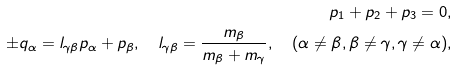Convert formula to latex. <formula><loc_0><loc_0><loc_500><loc_500>p _ { 1 } + p _ { 2 } + p _ { 3 } = 0 , \\ \pm q _ { \alpha } = l _ { \gamma \beta } p _ { \alpha } + p _ { \beta } , \quad l _ { \gamma \beta } = \frac { m _ { \beta } } { m _ { \beta } + m _ { \gamma } } , \quad ( \alpha \neq \beta , \beta \neq \gamma , \gamma \neq \alpha ) ,</formula> 